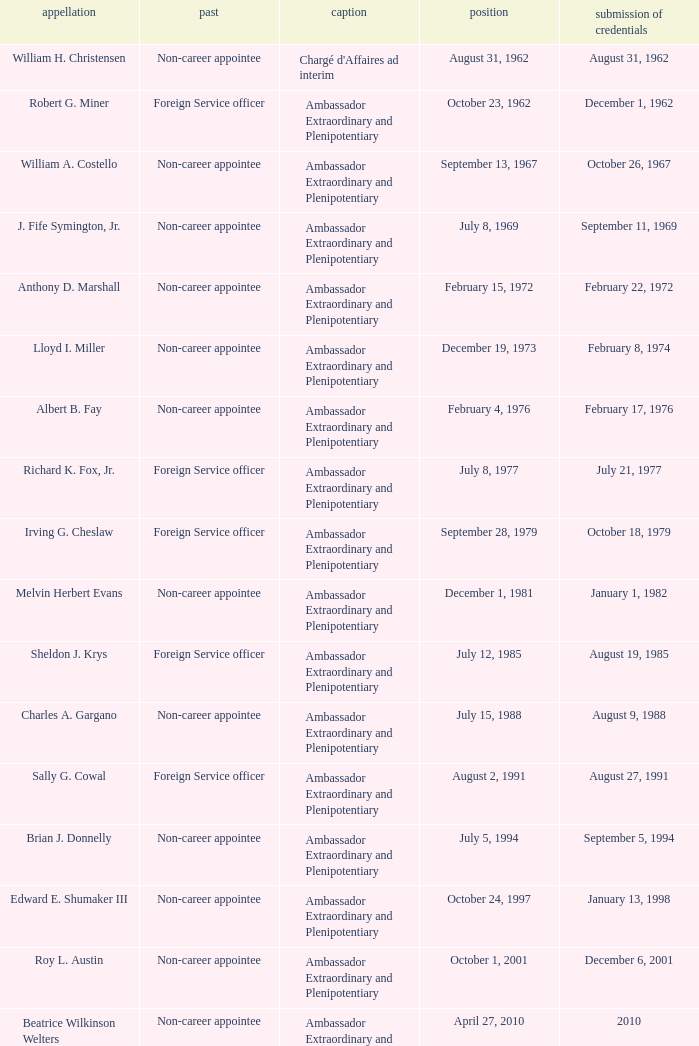Who was appointed on October 24, 1997? Edward E. Shumaker III. 